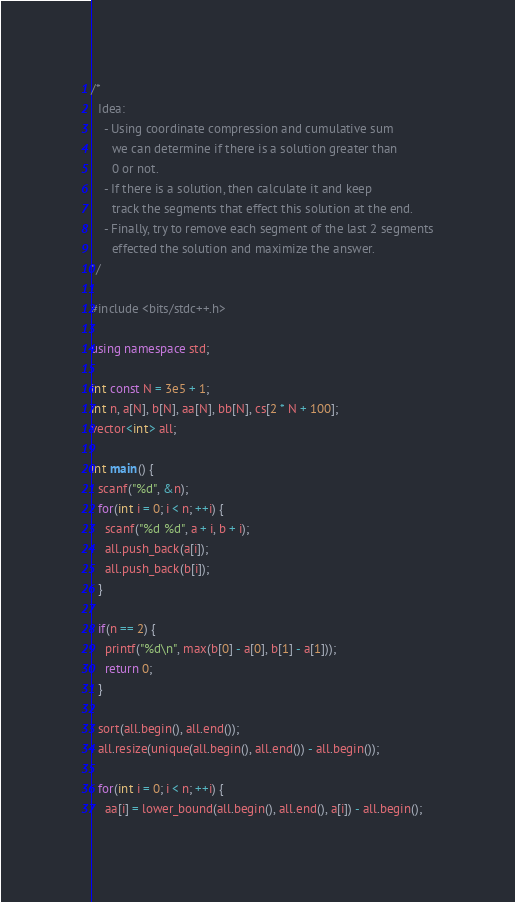<code> <loc_0><loc_0><loc_500><loc_500><_C++_>/*
  Idea:
    - Using coordinate compression and cumulative sum
      we can determine if there is a solution greater than
      0 or not.
    - If there is a solution, then calculate it and keep
      track the segments that effect this solution at the end.
    - Finally, try to remove each segment of the last 2 segments
      effected the solution and maximize the answer.
*/

#include <bits/stdc++.h>

using namespace std;

int const N = 3e5 + 1;
int n, a[N], b[N], aa[N], bb[N], cs[2 * N + 100];
vector<int> all;

int main() {
  scanf("%d", &n);
  for(int i = 0; i < n; ++i) {
    scanf("%d %d", a + i, b + i);
    all.push_back(a[i]);
    all.push_back(b[i]);
  }

  if(n == 2) {
    printf("%d\n", max(b[0] - a[0], b[1] - a[1]));
    return 0;
  }

  sort(all.begin(), all.end());
  all.resize(unique(all.begin(), all.end()) - all.begin());

  for(int i = 0; i < n; ++i) {
    aa[i] = lower_bound(all.begin(), all.end(), a[i]) - all.begin();</code> 